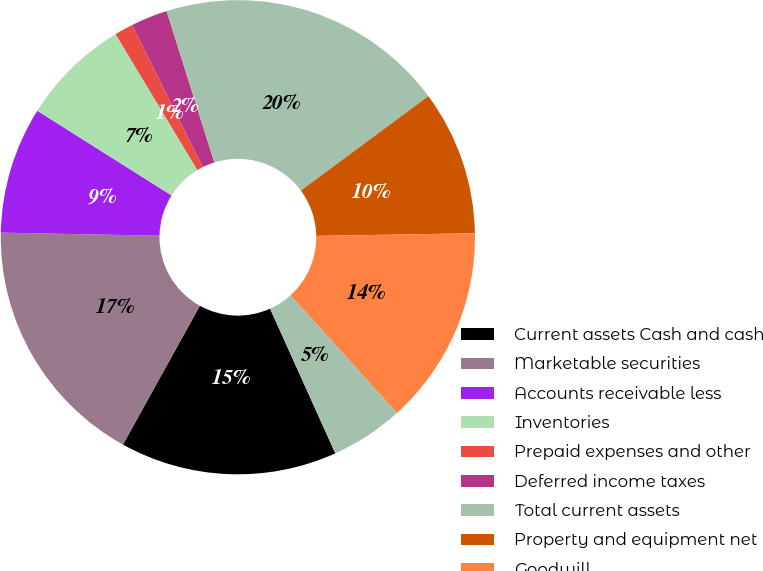<chart> <loc_0><loc_0><loc_500><loc_500><pie_chart><fcel>Current assets Cash and cash<fcel>Marketable securities<fcel>Accounts receivable less<fcel>Inventories<fcel>Prepaid expenses and other<fcel>Deferred income taxes<fcel>Total current assets<fcel>Property and equipment net<fcel>Goodwill<fcel>Intangible assets net<nl><fcel>14.8%<fcel>17.26%<fcel>8.65%<fcel>7.42%<fcel>1.27%<fcel>2.5%<fcel>19.72%<fcel>9.88%<fcel>13.57%<fcel>4.96%<nl></chart> 